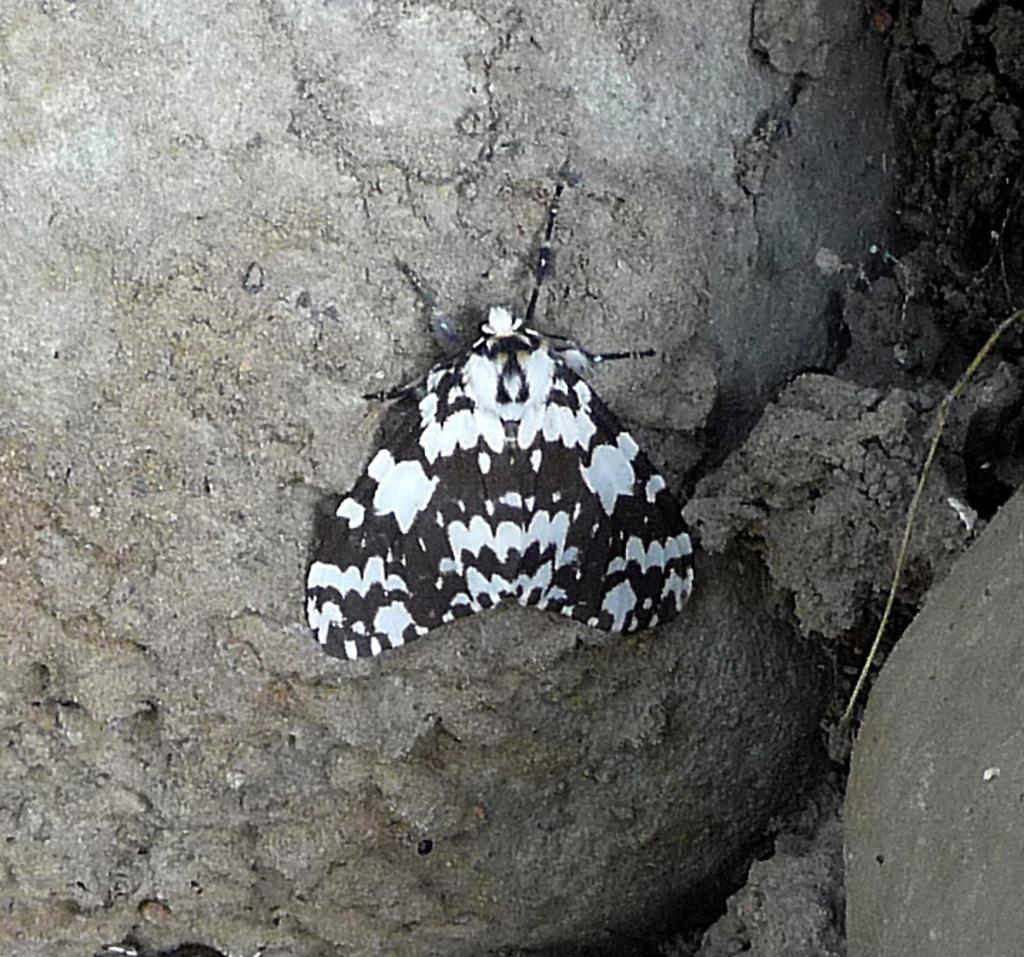What type of creature can be seen in the image? There is an insect in the image. Where is the insect located? The insect is on a rock surface. What type of sound does the insect make in the image? The image does not provide any information about the sound the insect might make, as it is a still image. 